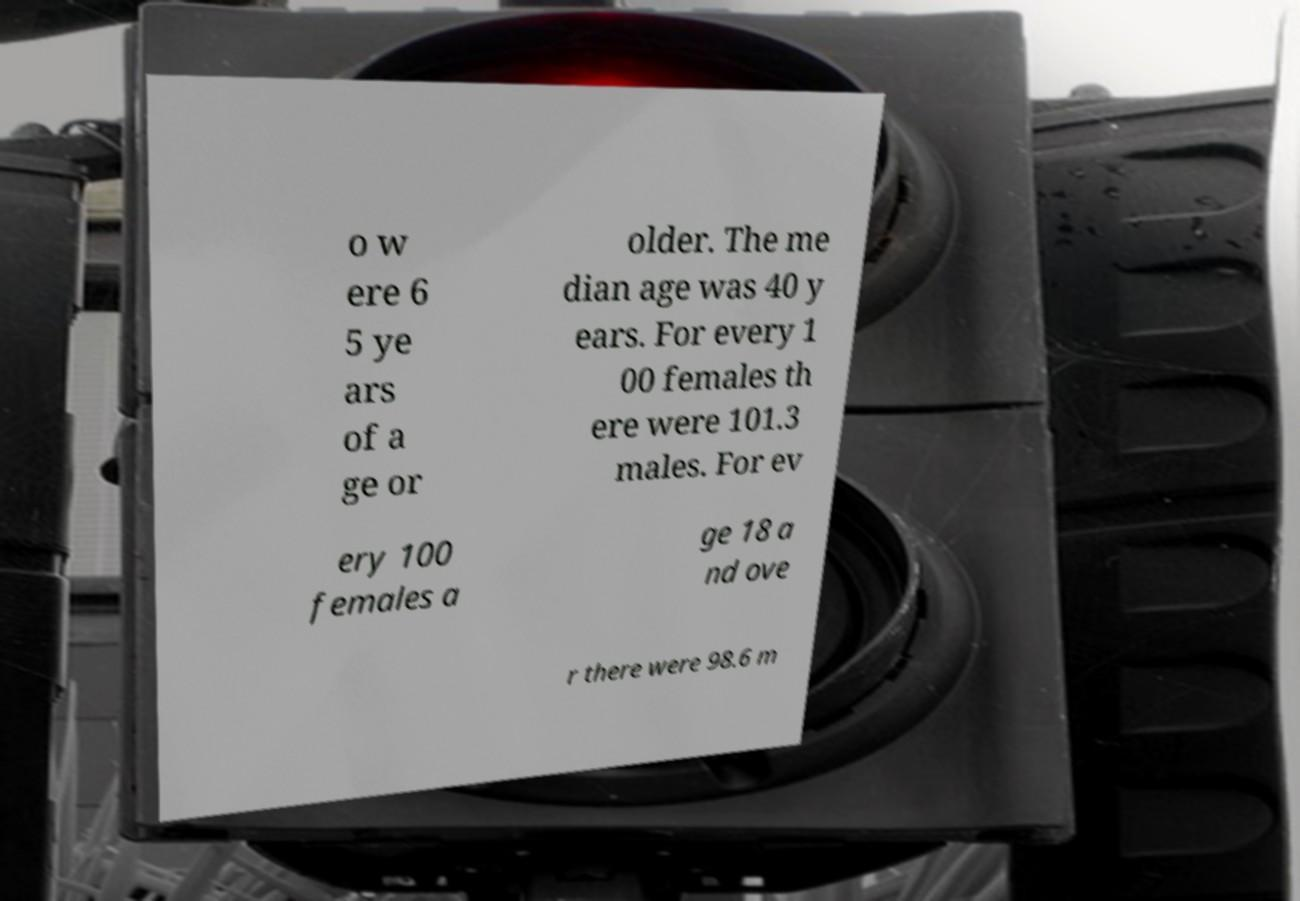Could you assist in decoding the text presented in this image and type it out clearly? o w ere 6 5 ye ars of a ge or older. The me dian age was 40 y ears. For every 1 00 females th ere were 101.3 males. For ev ery 100 females a ge 18 a nd ove r there were 98.6 m 